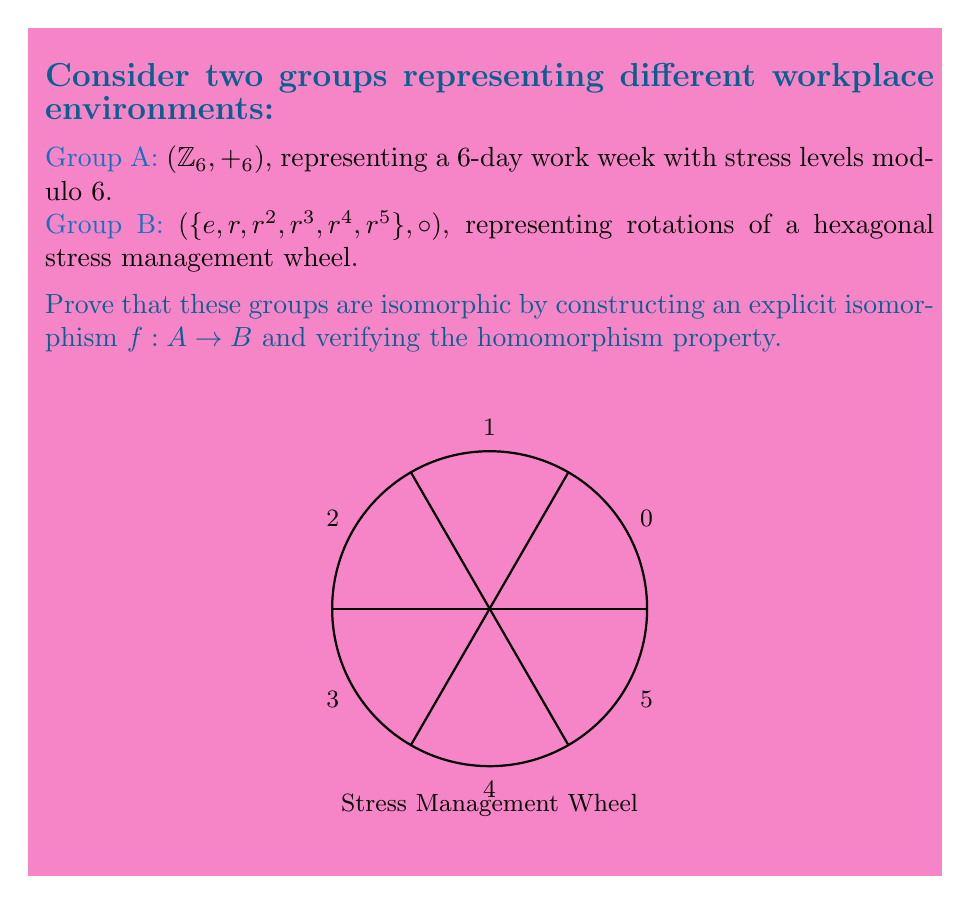Give your solution to this math problem. To prove that the groups A and B are isomorphic, we need to construct a bijective homomorphism $f: A \to B$. Let's approach this step-by-step:

1) First, let's define the mapping $f: A \to B$:
   $f(0) = e$
   $f(1) = r$
   $f(2) = r^2$
   $f(3) = r^3$
   $f(4) = r^4$
   $f(5) = r^5$

2) This mapping is clearly bijective as it maps each element of A to a unique element of B, and every element of B is mapped to.

3) Now, we need to verify the homomorphism property: $f(a +_6 b) = f(a) \circ f(b)$ for all $a, b \in A$.

4) Let's check this for a general case: $a +_6 b = c$ (mod 6)
   $f(a +_6 b) = f(c) = r^c$

5) On the other hand:
   $f(a) \circ f(b) = r^a \circ r^b = r^{a+b} = r^c$ (since $r^6 = e$ in group B)

6) This shows that $f(a +_6 b) = f(a) \circ f(b)$ for all $a, b \in A$.

7) Therefore, $f$ is an isomorphism between groups A and B.

In the context of workplace stress, this isomorphism demonstrates that the cyclic nature of a 6-day work week (with stress levels modulo 6) is structurally equivalent to the rotations of a hexagonal stress management wheel. This analogy could be useful in visualizing and managing occupational stress cycles.
Answer: $f: A \to B$ defined by $f(k) = r^k$ is an isomorphism. 